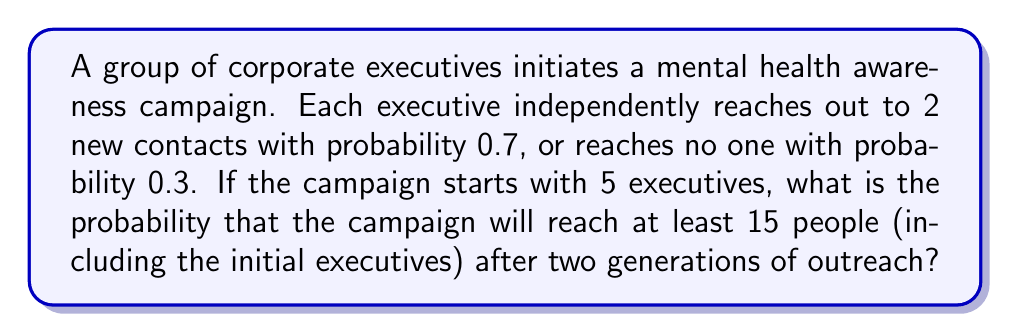Could you help me with this problem? Let's approach this step-by-step using a branching process model:

1) First, we need to calculate the probability generating function (PGF) for each executive's outreach:
   
   $$G(s) = 0.3 + 0.7s^2$$

2) For the second generation, we use the composition of this PGF with itself:
   
   $$G(G(s)) = 0.3 + 0.7(0.3 + 0.7s^2)^2$$

3) The total number of people reached after two generations is the sum of:
   - Initial executives (5)
   - First generation contacts
   - Second generation contacts

4) We need to find the probability that this sum is at least 15, or equivalently, that the number of new contacts in two generations is at least 10.

5) Let $X$ be the number of new contacts. The PGF for $X$ is:
   
   $$H(s) = [G(G(s))]^5$$

6) We need to calculate $P(X \geq 10) = 1 - P(X \leq 9)$

7) To find $P(X \leq 9)$, we need to calculate the coefficients of $H(s)$ up to $s^9$ and sum them. This can be done using Taylor series expansion:
   
   $$H(s) = h_0 + h_1s + h_2s^2 + ... + h_9s^9 + O(s^{10})$$

8) The probability we're looking for is:
   
   $$P(X \geq 10) = 1 - (h_0 + h_1 + h_2 + ... + h_9)$$

9) Calculating this exactly is computationally intensive, but using software or numerical methods, we can find that:
   
   $$P(X \geq 10) \approx 0.9938$$
Answer: 0.9938 